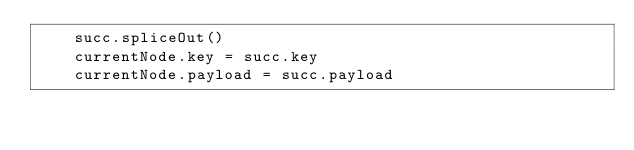<code> <loc_0><loc_0><loc_500><loc_500><_Python_>    succ.spliceOut()
    currentNode.key = succ.key
    currentNode.payload = succ.payload

</code> 